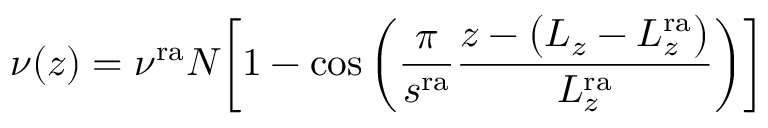Convert formula to latex. <formula><loc_0><loc_0><loc_500><loc_500>\nu ( z ) = \nu ^ { r a } N \left [ 1 - \cos { \left ( \frac { \pi } { s ^ { r a } } \frac { z - \left ( L _ { z } - L _ { z } ^ { r a } \right ) } { L _ { z } ^ { r a } } \right ) } \right ]</formula> 